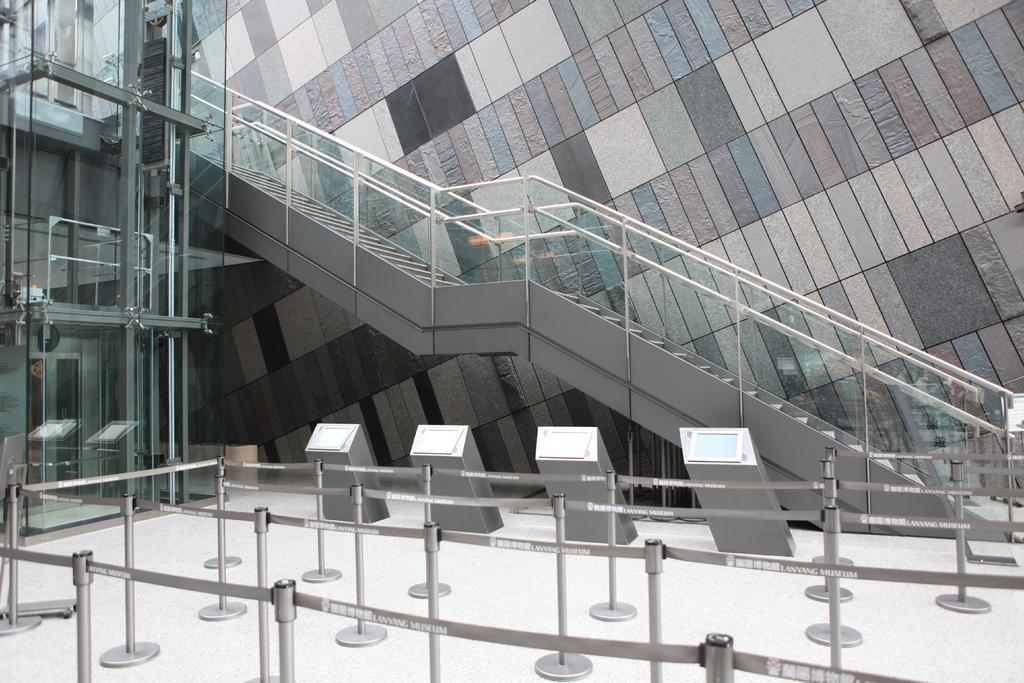What safety features are present in the foreground of the image? There are safety poles in the foreground of the image. What architectural feature can be seen in the background of the image? There is a staircase in the background of the image. What is behind the staircase in the image? There is a wall behind the staircase. What type of wall is present on the left side of the image? There is a glass wall on the left side of the image. What type of whistle can be heard in the image? There is no whistle present in the image, and therefore no sound can be heard. 